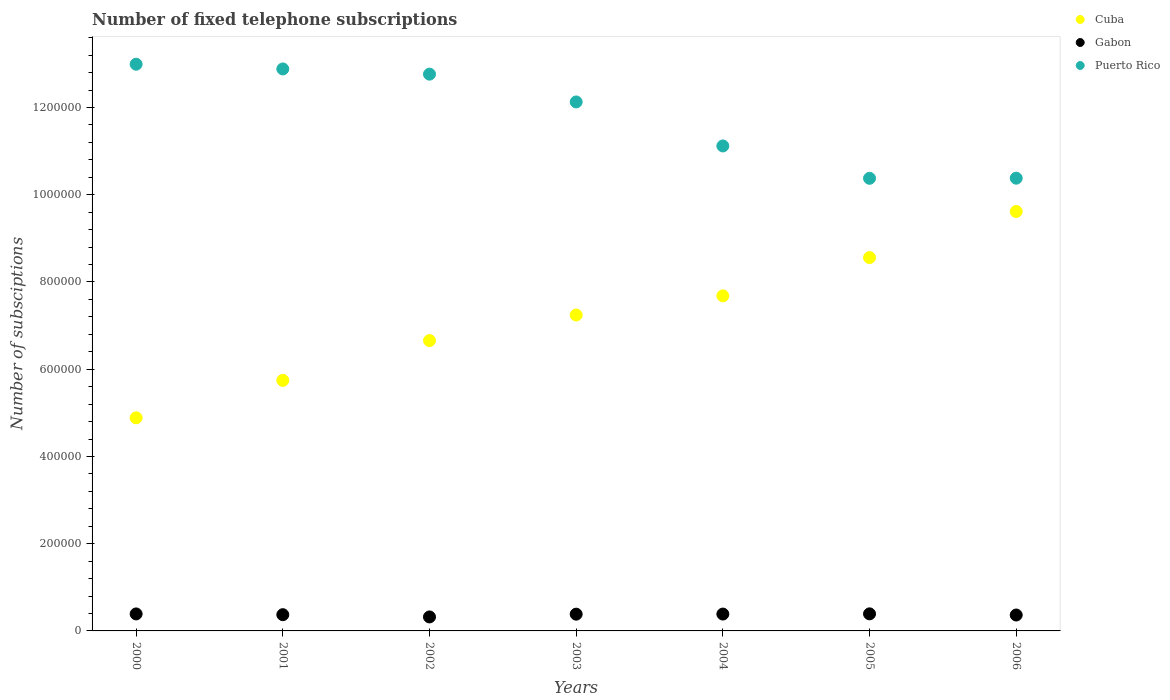How many different coloured dotlines are there?
Ensure brevity in your answer.  3. Is the number of dotlines equal to the number of legend labels?
Your answer should be very brief. Yes. What is the number of fixed telephone subscriptions in Puerto Rico in 2002?
Ensure brevity in your answer.  1.28e+06. Across all years, what is the maximum number of fixed telephone subscriptions in Gabon?
Keep it short and to the point. 3.91e+04. Across all years, what is the minimum number of fixed telephone subscriptions in Cuba?
Offer a very short reply. 4.89e+05. In which year was the number of fixed telephone subscriptions in Puerto Rico minimum?
Give a very brief answer. 2005. What is the total number of fixed telephone subscriptions in Gabon in the graph?
Offer a terse response. 2.61e+05. What is the difference between the number of fixed telephone subscriptions in Gabon in 2002 and that in 2004?
Provide a short and direct response. -6579. What is the difference between the number of fixed telephone subscriptions in Gabon in 2002 and the number of fixed telephone subscriptions in Puerto Rico in 2003?
Your answer should be very brief. -1.18e+06. What is the average number of fixed telephone subscriptions in Cuba per year?
Provide a short and direct response. 7.20e+05. In the year 2001, what is the difference between the number of fixed telephone subscriptions in Puerto Rico and number of fixed telephone subscriptions in Cuba?
Your answer should be very brief. 7.14e+05. What is the ratio of the number of fixed telephone subscriptions in Cuba in 2000 to that in 2001?
Make the answer very short. 0.85. Is the number of fixed telephone subscriptions in Puerto Rico in 2000 less than that in 2001?
Give a very brief answer. No. What is the difference between the highest and the second highest number of fixed telephone subscriptions in Puerto Rico?
Your answer should be very brief. 1.09e+04. What is the difference between the highest and the lowest number of fixed telephone subscriptions in Puerto Rico?
Give a very brief answer. 2.62e+05. In how many years, is the number of fixed telephone subscriptions in Puerto Rico greater than the average number of fixed telephone subscriptions in Puerto Rico taken over all years?
Your response must be concise. 4. Is the sum of the number of fixed telephone subscriptions in Gabon in 2001 and 2003 greater than the maximum number of fixed telephone subscriptions in Puerto Rico across all years?
Keep it short and to the point. No. Is it the case that in every year, the sum of the number of fixed telephone subscriptions in Puerto Rico and number of fixed telephone subscriptions in Gabon  is greater than the number of fixed telephone subscriptions in Cuba?
Keep it short and to the point. Yes. Is the number of fixed telephone subscriptions in Gabon strictly greater than the number of fixed telephone subscriptions in Cuba over the years?
Your response must be concise. No. How many dotlines are there?
Your answer should be compact. 3. Are the values on the major ticks of Y-axis written in scientific E-notation?
Make the answer very short. No. Where does the legend appear in the graph?
Your answer should be compact. Top right. What is the title of the graph?
Your answer should be very brief. Number of fixed telephone subscriptions. Does "Greenland" appear as one of the legend labels in the graph?
Your answer should be very brief. No. What is the label or title of the Y-axis?
Provide a short and direct response. Number of subsciptions. What is the Number of subsciptions of Cuba in 2000?
Your response must be concise. 4.89e+05. What is the Number of subsciptions of Gabon in 2000?
Make the answer very short. 3.90e+04. What is the Number of subsciptions in Puerto Rico in 2000?
Offer a terse response. 1.30e+06. What is the Number of subsciptions of Cuba in 2001?
Offer a very short reply. 5.74e+05. What is the Number of subsciptions in Gabon in 2001?
Keep it short and to the point. 3.72e+04. What is the Number of subsciptions in Puerto Rico in 2001?
Your answer should be very brief. 1.29e+06. What is the Number of subsciptions of Cuba in 2002?
Your answer should be very brief. 6.66e+05. What is the Number of subsciptions of Gabon in 2002?
Your answer should be very brief. 3.21e+04. What is the Number of subsciptions of Puerto Rico in 2002?
Your answer should be compact. 1.28e+06. What is the Number of subsciptions of Cuba in 2003?
Your answer should be very brief. 7.24e+05. What is the Number of subsciptions of Gabon in 2003?
Provide a short and direct response. 3.84e+04. What is the Number of subsciptions of Puerto Rico in 2003?
Give a very brief answer. 1.21e+06. What is the Number of subsciptions in Cuba in 2004?
Offer a terse response. 7.68e+05. What is the Number of subsciptions of Gabon in 2004?
Your answer should be very brief. 3.87e+04. What is the Number of subsciptions of Puerto Rico in 2004?
Your answer should be very brief. 1.11e+06. What is the Number of subsciptions of Cuba in 2005?
Make the answer very short. 8.56e+05. What is the Number of subsciptions in Gabon in 2005?
Your response must be concise. 3.91e+04. What is the Number of subsciptions of Puerto Rico in 2005?
Your response must be concise. 1.04e+06. What is the Number of subsciptions of Cuba in 2006?
Provide a succinct answer. 9.62e+05. What is the Number of subsciptions of Gabon in 2006?
Offer a terse response. 3.65e+04. What is the Number of subsciptions of Puerto Rico in 2006?
Your response must be concise. 1.04e+06. Across all years, what is the maximum Number of subsciptions of Cuba?
Offer a terse response. 9.62e+05. Across all years, what is the maximum Number of subsciptions of Gabon?
Offer a very short reply. 3.91e+04. Across all years, what is the maximum Number of subsciptions in Puerto Rico?
Your response must be concise. 1.30e+06. Across all years, what is the minimum Number of subsciptions of Cuba?
Provide a succinct answer. 4.89e+05. Across all years, what is the minimum Number of subsciptions of Gabon?
Provide a succinct answer. 3.21e+04. Across all years, what is the minimum Number of subsciptions in Puerto Rico?
Make the answer very short. 1.04e+06. What is the total Number of subsciptions of Cuba in the graph?
Your response must be concise. 5.04e+06. What is the total Number of subsciptions of Gabon in the graph?
Make the answer very short. 2.61e+05. What is the total Number of subsciptions in Puerto Rico in the graph?
Keep it short and to the point. 8.26e+06. What is the difference between the Number of subsciptions in Cuba in 2000 and that in 2001?
Provide a short and direct response. -8.58e+04. What is the difference between the Number of subsciptions of Gabon in 2000 and that in 2001?
Keep it short and to the point. 1741. What is the difference between the Number of subsciptions of Puerto Rico in 2000 and that in 2001?
Offer a terse response. 1.09e+04. What is the difference between the Number of subsciptions in Cuba in 2000 and that in 2002?
Your response must be concise. -1.77e+05. What is the difference between the Number of subsciptions in Gabon in 2000 and that in 2002?
Your response must be concise. 6899. What is the difference between the Number of subsciptions in Puerto Rico in 2000 and that in 2002?
Offer a very short reply. 2.28e+04. What is the difference between the Number of subsciptions of Cuba in 2000 and that in 2003?
Ensure brevity in your answer.  -2.36e+05. What is the difference between the Number of subsciptions of Gabon in 2000 and that in 2003?
Provide a short and direct response. 559. What is the difference between the Number of subsciptions in Puerto Rico in 2000 and that in 2003?
Give a very brief answer. 8.65e+04. What is the difference between the Number of subsciptions in Cuba in 2000 and that in 2004?
Offer a terse response. -2.80e+05. What is the difference between the Number of subsciptions of Gabon in 2000 and that in 2004?
Ensure brevity in your answer.  320. What is the difference between the Number of subsciptions of Puerto Rico in 2000 and that in 2004?
Provide a succinct answer. 1.87e+05. What is the difference between the Number of subsciptions of Cuba in 2000 and that in 2005?
Your answer should be compact. -3.67e+05. What is the difference between the Number of subsciptions in Gabon in 2000 and that in 2005?
Your response must be concise. -154. What is the difference between the Number of subsciptions of Puerto Rico in 2000 and that in 2005?
Provide a succinct answer. 2.62e+05. What is the difference between the Number of subsciptions of Cuba in 2000 and that in 2006?
Your response must be concise. -4.73e+05. What is the difference between the Number of subsciptions in Gabon in 2000 and that in 2006?
Make the answer very short. 2498. What is the difference between the Number of subsciptions in Puerto Rico in 2000 and that in 2006?
Your answer should be compact. 2.61e+05. What is the difference between the Number of subsciptions of Cuba in 2001 and that in 2002?
Your answer should be compact. -9.12e+04. What is the difference between the Number of subsciptions in Gabon in 2001 and that in 2002?
Provide a succinct answer. 5158. What is the difference between the Number of subsciptions in Puerto Rico in 2001 and that in 2002?
Ensure brevity in your answer.  1.19e+04. What is the difference between the Number of subsciptions of Cuba in 2001 and that in 2003?
Keep it short and to the point. -1.50e+05. What is the difference between the Number of subsciptions in Gabon in 2001 and that in 2003?
Provide a succinct answer. -1182. What is the difference between the Number of subsciptions of Puerto Rico in 2001 and that in 2003?
Your response must be concise. 7.57e+04. What is the difference between the Number of subsciptions of Cuba in 2001 and that in 2004?
Give a very brief answer. -1.94e+05. What is the difference between the Number of subsciptions of Gabon in 2001 and that in 2004?
Your answer should be compact. -1421. What is the difference between the Number of subsciptions in Puerto Rico in 2001 and that in 2004?
Your answer should be compact. 1.77e+05. What is the difference between the Number of subsciptions of Cuba in 2001 and that in 2005?
Your answer should be very brief. -2.82e+05. What is the difference between the Number of subsciptions of Gabon in 2001 and that in 2005?
Keep it short and to the point. -1895. What is the difference between the Number of subsciptions of Puerto Rico in 2001 and that in 2005?
Your answer should be compact. 2.51e+05. What is the difference between the Number of subsciptions in Cuba in 2001 and that in 2006?
Provide a short and direct response. -3.87e+05. What is the difference between the Number of subsciptions of Gabon in 2001 and that in 2006?
Your answer should be compact. 757. What is the difference between the Number of subsciptions of Puerto Rico in 2001 and that in 2006?
Keep it short and to the point. 2.50e+05. What is the difference between the Number of subsciptions in Cuba in 2002 and that in 2003?
Provide a succinct answer. -5.86e+04. What is the difference between the Number of subsciptions of Gabon in 2002 and that in 2003?
Give a very brief answer. -6340. What is the difference between the Number of subsciptions of Puerto Rico in 2002 and that in 2003?
Provide a succinct answer. 6.37e+04. What is the difference between the Number of subsciptions in Cuba in 2002 and that in 2004?
Your answer should be very brief. -1.03e+05. What is the difference between the Number of subsciptions in Gabon in 2002 and that in 2004?
Offer a very short reply. -6579. What is the difference between the Number of subsciptions of Puerto Rico in 2002 and that in 2004?
Your answer should be very brief. 1.65e+05. What is the difference between the Number of subsciptions of Cuba in 2002 and that in 2005?
Your response must be concise. -1.90e+05. What is the difference between the Number of subsciptions of Gabon in 2002 and that in 2005?
Provide a short and direct response. -7053. What is the difference between the Number of subsciptions in Puerto Rico in 2002 and that in 2005?
Provide a succinct answer. 2.39e+05. What is the difference between the Number of subsciptions in Cuba in 2002 and that in 2006?
Offer a very short reply. -2.96e+05. What is the difference between the Number of subsciptions in Gabon in 2002 and that in 2006?
Keep it short and to the point. -4401. What is the difference between the Number of subsciptions in Puerto Rico in 2002 and that in 2006?
Your answer should be very brief. 2.38e+05. What is the difference between the Number of subsciptions in Cuba in 2003 and that in 2004?
Make the answer very short. -4.39e+04. What is the difference between the Number of subsciptions in Gabon in 2003 and that in 2004?
Give a very brief answer. -239. What is the difference between the Number of subsciptions of Puerto Rico in 2003 and that in 2004?
Offer a very short reply. 1.01e+05. What is the difference between the Number of subsciptions in Cuba in 2003 and that in 2005?
Provide a succinct answer. -1.32e+05. What is the difference between the Number of subsciptions in Gabon in 2003 and that in 2005?
Make the answer very short. -713. What is the difference between the Number of subsciptions in Puerto Rico in 2003 and that in 2005?
Your answer should be very brief. 1.75e+05. What is the difference between the Number of subsciptions of Cuba in 2003 and that in 2006?
Ensure brevity in your answer.  -2.37e+05. What is the difference between the Number of subsciptions of Gabon in 2003 and that in 2006?
Your answer should be compact. 1939. What is the difference between the Number of subsciptions of Puerto Rico in 2003 and that in 2006?
Make the answer very short. 1.75e+05. What is the difference between the Number of subsciptions in Cuba in 2004 and that in 2005?
Make the answer very short. -8.78e+04. What is the difference between the Number of subsciptions in Gabon in 2004 and that in 2005?
Give a very brief answer. -474. What is the difference between the Number of subsciptions of Puerto Rico in 2004 and that in 2005?
Provide a succinct answer. 7.42e+04. What is the difference between the Number of subsciptions in Cuba in 2004 and that in 2006?
Give a very brief answer. -1.93e+05. What is the difference between the Number of subsciptions of Gabon in 2004 and that in 2006?
Make the answer very short. 2178. What is the difference between the Number of subsciptions in Puerto Rico in 2004 and that in 2006?
Offer a terse response. 7.39e+04. What is the difference between the Number of subsciptions of Cuba in 2005 and that in 2006?
Provide a short and direct response. -1.06e+05. What is the difference between the Number of subsciptions of Gabon in 2005 and that in 2006?
Make the answer very short. 2652. What is the difference between the Number of subsciptions of Puerto Rico in 2005 and that in 2006?
Give a very brief answer. -300. What is the difference between the Number of subsciptions in Cuba in 2000 and the Number of subsciptions in Gabon in 2001?
Offer a terse response. 4.51e+05. What is the difference between the Number of subsciptions of Cuba in 2000 and the Number of subsciptions of Puerto Rico in 2001?
Ensure brevity in your answer.  -8.00e+05. What is the difference between the Number of subsciptions in Gabon in 2000 and the Number of subsciptions in Puerto Rico in 2001?
Make the answer very short. -1.25e+06. What is the difference between the Number of subsciptions of Cuba in 2000 and the Number of subsciptions of Gabon in 2002?
Provide a short and direct response. 4.57e+05. What is the difference between the Number of subsciptions of Cuba in 2000 and the Number of subsciptions of Puerto Rico in 2002?
Give a very brief answer. -7.88e+05. What is the difference between the Number of subsciptions of Gabon in 2000 and the Number of subsciptions of Puerto Rico in 2002?
Offer a terse response. -1.24e+06. What is the difference between the Number of subsciptions of Cuba in 2000 and the Number of subsciptions of Gabon in 2003?
Your answer should be very brief. 4.50e+05. What is the difference between the Number of subsciptions of Cuba in 2000 and the Number of subsciptions of Puerto Rico in 2003?
Provide a short and direct response. -7.24e+05. What is the difference between the Number of subsciptions in Gabon in 2000 and the Number of subsciptions in Puerto Rico in 2003?
Offer a very short reply. -1.17e+06. What is the difference between the Number of subsciptions in Cuba in 2000 and the Number of subsciptions in Gabon in 2004?
Provide a short and direct response. 4.50e+05. What is the difference between the Number of subsciptions in Cuba in 2000 and the Number of subsciptions in Puerto Rico in 2004?
Offer a very short reply. -6.23e+05. What is the difference between the Number of subsciptions of Gabon in 2000 and the Number of subsciptions of Puerto Rico in 2004?
Offer a very short reply. -1.07e+06. What is the difference between the Number of subsciptions in Cuba in 2000 and the Number of subsciptions in Gabon in 2005?
Offer a terse response. 4.49e+05. What is the difference between the Number of subsciptions of Cuba in 2000 and the Number of subsciptions of Puerto Rico in 2005?
Offer a terse response. -5.49e+05. What is the difference between the Number of subsciptions of Gabon in 2000 and the Number of subsciptions of Puerto Rico in 2005?
Ensure brevity in your answer.  -9.99e+05. What is the difference between the Number of subsciptions in Cuba in 2000 and the Number of subsciptions in Gabon in 2006?
Offer a terse response. 4.52e+05. What is the difference between the Number of subsciptions of Cuba in 2000 and the Number of subsciptions of Puerto Rico in 2006?
Your answer should be very brief. -5.49e+05. What is the difference between the Number of subsciptions of Gabon in 2000 and the Number of subsciptions of Puerto Rico in 2006?
Provide a short and direct response. -9.99e+05. What is the difference between the Number of subsciptions of Cuba in 2001 and the Number of subsciptions of Gabon in 2002?
Keep it short and to the point. 5.42e+05. What is the difference between the Number of subsciptions of Cuba in 2001 and the Number of subsciptions of Puerto Rico in 2002?
Provide a succinct answer. -7.02e+05. What is the difference between the Number of subsciptions of Gabon in 2001 and the Number of subsciptions of Puerto Rico in 2002?
Your answer should be compact. -1.24e+06. What is the difference between the Number of subsciptions of Cuba in 2001 and the Number of subsciptions of Gabon in 2003?
Your response must be concise. 5.36e+05. What is the difference between the Number of subsciptions in Cuba in 2001 and the Number of subsciptions in Puerto Rico in 2003?
Ensure brevity in your answer.  -6.38e+05. What is the difference between the Number of subsciptions of Gabon in 2001 and the Number of subsciptions of Puerto Rico in 2003?
Your answer should be very brief. -1.18e+06. What is the difference between the Number of subsciptions of Cuba in 2001 and the Number of subsciptions of Gabon in 2004?
Your answer should be compact. 5.36e+05. What is the difference between the Number of subsciptions in Cuba in 2001 and the Number of subsciptions in Puerto Rico in 2004?
Your response must be concise. -5.37e+05. What is the difference between the Number of subsciptions in Gabon in 2001 and the Number of subsciptions in Puerto Rico in 2004?
Provide a succinct answer. -1.07e+06. What is the difference between the Number of subsciptions of Cuba in 2001 and the Number of subsciptions of Gabon in 2005?
Ensure brevity in your answer.  5.35e+05. What is the difference between the Number of subsciptions of Cuba in 2001 and the Number of subsciptions of Puerto Rico in 2005?
Your answer should be compact. -4.63e+05. What is the difference between the Number of subsciptions of Gabon in 2001 and the Number of subsciptions of Puerto Rico in 2005?
Ensure brevity in your answer.  -1.00e+06. What is the difference between the Number of subsciptions in Cuba in 2001 and the Number of subsciptions in Gabon in 2006?
Ensure brevity in your answer.  5.38e+05. What is the difference between the Number of subsciptions in Cuba in 2001 and the Number of subsciptions in Puerto Rico in 2006?
Your answer should be very brief. -4.64e+05. What is the difference between the Number of subsciptions in Gabon in 2001 and the Number of subsciptions in Puerto Rico in 2006?
Offer a very short reply. -1.00e+06. What is the difference between the Number of subsciptions in Cuba in 2002 and the Number of subsciptions in Gabon in 2003?
Your answer should be compact. 6.27e+05. What is the difference between the Number of subsciptions of Cuba in 2002 and the Number of subsciptions of Puerto Rico in 2003?
Keep it short and to the point. -5.47e+05. What is the difference between the Number of subsciptions in Gabon in 2002 and the Number of subsciptions in Puerto Rico in 2003?
Provide a succinct answer. -1.18e+06. What is the difference between the Number of subsciptions of Cuba in 2002 and the Number of subsciptions of Gabon in 2004?
Provide a succinct answer. 6.27e+05. What is the difference between the Number of subsciptions in Cuba in 2002 and the Number of subsciptions in Puerto Rico in 2004?
Keep it short and to the point. -4.46e+05. What is the difference between the Number of subsciptions of Gabon in 2002 and the Number of subsciptions of Puerto Rico in 2004?
Your answer should be very brief. -1.08e+06. What is the difference between the Number of subsciptions of Cuba in 2002 and the Number of subsciptions of Gabon in 2005?
Ensure brevity in your answer.  6.27e+05. What is the difference between the Number of subsciptions of Cuba in 2002 and the Number of subsciptions of Puerto Rico in 2005?
Ensure brevity in your answer.  -3.72e+05. What is the difference between the Number of subsciptions of Gabon in 2002 and the Number of subsciptions of Puerto Rico in 2005?
Keep it short and to the point. -1.01e+06. What is the difference between the Number of subsciptions of Cuba in 2002 and the Number of subsciptions of Gabon in 2006?
Your answer should be compact. 6.29e+05. What is the difference between the Number of subsciptions of Cuba in 2002 and the Number of subsciptions of Puerto Rico in 2006?
Offer a very short reply. -3.72e+05. What is the difference between the Number of subsciptions in Gabon in 2002 and the Number of subsciptions in Puerto Rico in 2006?
Your answer should be compact. -1.01e+06. What is the difference between the Number of subsciptions in Cuba in 2003 and the Number of subsciptions in Gabon in 2004?
Ensure brevity in your answer.  6.86e+05. What is the difference between the Number of subsciptions in Cuba in 2003 and the Number of subsciptions in Puerto Rico in 2004?
Your response must be concise. -3.88e+05. What is the difference between the Number of subsciptions of Gabon in 2003 and the Number of subsciptions of Puerto Rico in 2004?
Offer a terse response. -1.07e+06. What is the difference between the Number of subsciptions in Cuba in 2003 and the Number of subsciptions in Gabon in 2005?
Provide a short and direct response. 6.85e+05. What is the difference between the Number of subsciptions of Cuba in 2003 and the Number of subsciptions of Puerto Rico in 2005?
Ensure brevity in your answer.  -3.13e+05. What is the difference between the Number of subsciptions of Gabon in 2003 and the Number of subsciptions of Puerto Rico in 2005?
Provide a short and direct response. -9.99e+05. What is the difference between the Number of subsciptions of Cuba in 2003 and the Number of subsciptions of Gabon in 2006?
Make the answer very short. 6.88e+05. What is the difference between the Number of subsciptions in Cuba in 2003 and the Number of subsciptions in Puerto Rico in 2006?
Keep it short and to the point. -3.14e+05. What is the difference between the Number of subsciptions of Gabon in 2003 and the Number of subsciptions of Puerto Rico in 2006?
Give a very brief answer. -1.00e+06. What is the difference between the Number of subsciptions of Cuba in 2004 and the Number of subsciptions of Gabon in 2005?
Offer a terse response. 7.29e+05. What is the difference between the Number of subsciptions of Cuba in 2004 and the Number of subsciptions of Puerto Rico in 2005?
Offer a very short reply. -2.70e+05. What is the difference between the Number of subsciptions in Gabon in 2004 and the Number of subsciptions in Puerto Rico in 2005?
Provide a succinct answer. -9.99e+05. What is the difference between the Number of subsciptions in Cuba in 2004 and the Number of subsciptions in Gabon in 2006?
Provide a short and direct response. 7.32e+05. What is the difference between the Number of subsciptions in Cuba in 2004 and the Number of subsciptions in Puerto Rico in 2006?
Your answer should be compact. -2.70e+05. What is the difference between the Number of subsciptions in Gabon in 2004 and the Number of subsciptions in Puerto Rico in 2006?
Keep it short and to the point. -9.99e+05. What is the difference between the Number of subsciptions in Cuba in 2005 and the Number of subsciptions in Gabon in 2006?
Provide a succinct answer. 8.19e+05. What is the difference between the Number of subsciptions in Cuba in 2005 and the Number of subsciptions in Puerto Rico in 2006?
Your answer should be very brief. -1.82e+05. What is the difference between the Number of subsciptions in Gabon in 2005 and the Number of subsciptions in Puerto Rico in 2006?
Keep it short and to the point. -9.99e+05. What is the average Number of subsciptions of Cuba per year?
Your response must be concise. 7.20e+05. What is the average Number of subsciptions in Gabon per year?
Ensure brevity in your answer.  3.73e+04. What is the average Number of subsciptions of Puerto Rico per year?
Make the answer very short. 1.18e+06. In the year 2000, what is the difference between the Number of subsciptions in Cuba and Number of subsciptions in Gabon?
Ensure brevity in your answer.  4.50e+05. In the year 2000, what is the difference between the Number of subsciptions of Cuba and Number of subsciptions of Puerto Rico?
Provide a short and direct response. -8.11e+05. In the year 2000, what is the difference between the Number of subsciptions in Gabon and Number of subsciptions in Puerto Rico?
Give a very brief answer. -1.26e+06. In the year 2001, what is the difference between the Number of subsciptions in Cuba and Number of subsciptions in Gabon?
Ensure brevity in your answer.  5.37e+05. In the year 2001, what is the difference between the Number of subsciptions of Cuba and Number of subsciptions of Puerto Rico?
Keep it short and to the point. -7.14e+05. In the year 2001, what is the difference between the Number of subsciptions of Gabon and Number of subsciptions of Puerto Rico?
Your answer should be compact. -1.25e+06. In the year 2002, what is the difference between the Number of subsciptions in Cuba and Number of subsciptions in Gabon?
Offer a very short reply. 6.34e+05. In the year 2002, what is the difference between the Number of subsciptions of Cuba and Number of subsciptions of Puerto Rico?
Offer a terse response. -6.11e+05. In the year 2002, what is the difference between the Number of subsciptions of Gabon and Number of subsciptions of Puerto Rico?
Your answer should be compact. -1.24e+06. In the year 2003, what is the difference between the Number of subsciptions in Cuba and Number of subsciptions in Gabon?
Offer a very short reply. 6.86e+05. In the year 2003, what is the difference between the Number of subsciptions of Cuba and Number of subsciptions of Puerto Rico?
Your answer should be compact. -4.89e+05. In the year 2003, what is the difference between the Number of subsciptions in Gabon and Number of subsciptions in Puerto Rico?
Offer a terse response. -1.17e+06. In the year 2004, what is the difference between the Number of subsciptions in Cuba and Number of subsciptions in Gabon?
Give a very brief answer. 7.30e+05. In the year 2004, what is the difference between the Number of subsciptions of Cuba and Number of subsciptions of Puerto Rico?
Offer a terse response. -3.44e+05. In the year 2004, what is the difference between the Number of subsciptions of Gabon and Number of subsciptions of Puerto Rico?
Offer a very short reply. -1.07e+06. In the year 2005, what is the difference between the Number of subsciptions in Cuba and Number of subsciptions in Gabon?
Provide a short and direct response. 8.17e+05. In the year 2005, what is the difference between the Number of subsciptions in Cuba and Number of subsciptions in Puerto Rico?
Give a very brief answer. -1.82e+05. In the year 2005, what is the difference between the Number of subsciptions in Gabon and Number of subsciptions in Puerto Rico?
Offer a very short reply. -9.99e+05. In the year 2006, what is the difference between the Number of subsciptions in Cuba and Number of subsciptions in Gabon?
Offer a very short reply. 9.25e+05. In the year 2006, what is the difference between the Number of subsciptions in Cuba and Number of subsciptions in Puerto Rico?
Offer a very short reply. -7.64e+04. In the year 2006, what is the difference between the Number of subsciptions of Gabon and Number of subsciptions of Puerto Rico?
Make the answer very short. -1.00e+06. What is the ratio of the Number of subsciptions of Cuba in 2000 to that in 2001?
Provide a succinct answer. 0.85. What is the ratio of the Number of subsciptions of Gabon in 2000 to that in 2001?
Provide a short and direct response. 1.05. What is the ratio of the Number of subsciptions in Puerto Rico in 2000 to that in 2001?
Make the answer very short. 1.01. What is the ratio of the Number of subsciptions of Cuba in 2000 to that in 2002?
Your answer should be compact. 0.73. What is the ratio of the Number of subsciptions in Gabon in 2000 to that in 2002?
Your answer should be very brief. 1.22. What is the ratio of the Number of subsciptions in Puerto Rico in 2000 to that in 2002?
Offer a very short reply. 1.02. What is the ratio of the Number of subsciptions in Cuba in 2000 to that in 2003?
Ensure brevity in your answer.  0.67. What is the ratio of the Number of subsciptions in Gabon in 2000 to that in 2003?
Keep it short and to the point. 1.01. What is the ratio of the Number of subsciptions of Puerto Rico in 2000 to that in 2003?
Offer a terse response. 1.07. What is the ratio of the Number of subsciptions in Cuba in 2000 to that in 2004?
Offer a terse response. 0.64. What is the ratio of the Number of subsciptions of Gabon in 2000 to that in 2004?
Offer a terse response. 1.01. What is the ratio of the Number of subsciptions in Puerto Rico in 2000 to that in 2004?
Your response must be concise. 1.17. What is the ratio of the Number of subsciptions in Cuba in 2000 to that in 2005?
Provide a succinct answer. 0.57. What is the ratio of the Number of subsciptions in Gabon in 2000 to that in 2005?
Ensure brevity in your answer.  1. What is the ratio of the Number of subsciptions of Puerto Rico in 2000 to that in 2005?
Offer a very short reply. 1.25. What is the ratio of the Number of subsciptions of Cuba in 2000 to that in 2006?
Ensure brevity in your answer.  0.51. What is the ratio of the Number of subsciptions in Gabon in 2000 to that in 2006?
Offer a very short reply. 1.07. What is the ratio of the Number of subsciptions in Puerto Rico in 2000 to that in 2006?
Your answer should be compact. 1.25. What is the ratio of the Number of subsciptions of Cuba in 2001 to that in 2002?
Ensure brevity in your answer.  0.86. What is the ratio of the Number of subsciptions in Gabon in 2001 to that in 2002?
Keep it short and to the point. 1.16. What is the ratio of the Number of subsciptions in Puerto Rico in 2001 to that in 2002?
Offer a terse response. 1.01. What is the ratio of the Number of subsciptions in Cuba in 2001 to that in 2003?
Your answer should be compact. 0.79. What is the ratio of the Number of subsciptions in Gabon in 2001 to that in 2003?
Keep it short and to the point. 0.97. What is the ratio of the Number of subsciptions of Puerto Rico in 2001 to that in 2003?
Give a very brief answer. 1.06. What is the ratio of the Number of subsciptions in Cuba in 2001 to that in 2004?
Your answer should be very brief. 0.75. What is the ratio of the Number of subsciptions in Gabon in 2001 to that in 2004?
Your answer should be very brief. 0.96. What is the ratio of the Number of subsciptions in Puerto Rico in 2001 to that in 2004?
Give a very brief answer. 1.16. What is the ratio of the Number of subsciptions in Cuba in 2001 to that in 2005?
Make the answer very short. 0.67. What is the ratio of the Number of subsciptions in Gabon in 2001 to that in 2005?
Your answer should be compact. 0.95. What is the ratio of the Number of subsciptions of Puerto Rico in 2001 to that in 2005?
Your response must be concise. 1.24. What is the ratio of the Number of subsciptions in Cuba in 2001 to that in 2006?
Provide a succinct answer. 0.6. What is the ratio of the Number of subsciptions of Gabon in 2001 to that in 2006?
Offer a terse response. 1.02. What is the ratio of the Number of subsciptions in Puerto Rico in 2001 to that in 2006?
Provide a succinct answer. 1.24. What is the ratio of the Number of subsciptions of Cuba in 2002 to that in 2003?
Offer a terse response. 0.92. What is the ratio of the Number of subsciptions in Gabon in 2002 to that in 2003?
Provide a succinct answer. 0.83. What is the ratio of the Number of subsciptions in Puerto Rico in 2002 to that in 2003?
Make the answer very short. 1.05. What is the ratio of the Number of subsciptions of Cuba in 2002 to that in 2004?
Provide a short and direct response. 0.87. What is the ratio of the Number of subsciptions of Gabon in 2002 to that in 2004?
Offer a terse response. 0.83. What is the ratio of the Number of subsciptions of Puerto Rico in 2002 to that in 2004?
Provide a succinct answer. 1.15. What is the ratio of the Number of subsciptions in Cuba in 2002 to that in 2005?
Ensure brevity in your answer.  0.78. What is the ratio of the Number of subsciptions in Gabon in 2002 to that in 2005?
Give a very brief answer. 0.82. What is the ratio of the Number of subsciptions of Puerto Rico in 2002 to that in 2005?
Your response must be concise. 1.23. What is the ratio of the Number of subsciptions in Cuba in 2002 to that in 2006?
Provide a short and direct response. 0.69. What is the ratio of the Number of subsciptions of Gabon in 2002 to that in 2006?
Your response must be concise. 0.88. What is the ratio of the Number of subsciptions of Puerto Rico in 2002 to that in 2006?
Provide a succinct answer. 1.23. What is the ratio of the Number of subsciptions in Cuba in 2003 to that in 2004?
Keep it short and to the point. 0.94. What is the ratio of the Number of subsciptions in Gabon in 2003 to that in 2004?
Offer a terse response. 0.99. What is the ratio of the Number of subsciptions of Puerto Rico in 2003 to that in 2004?
Keep it short and to the point. 1.09. What is the ratio of the Number of subsciptions of Cuba in 2003 to that in 2005?
Provide a succinct answer. 0.85. What is the ratio of the Number of subsciptions in Gabon in 2003 to that in 2005?
Make the answer very short. 0.98. What is the ratio of the Number of subsciptions of Puerto Rico in 2003 to that in 2005?
Make the answer very short. 1.17. What is the ratio of the Number of subsciptions of Cuba in 2003 to that in 2006?
Your answer should be compact. 0.75. What is the ratio of the Number of subsciptions in Gabon in 2003 to that in 2006?
Your answer should be compact. 1.05. What is the ratio of the Number of subsciptions of Puerto Rico in 2003 to that in 2006?
Your response must be concise. 1.17. What is the ratio of the Number of subsciptions in Cuba in 2004 to that in 2005?
Keep it short and to the point. 0.9. What is the ratio of the Number of subsciptions in Gabon in 2004 to that in 2005?
Your answer should be very brief. 0.99. What is the ratio of the Number of subsciptions of Puerto Rico in 2004 to that in 2005?
Make the answer very short. 1.07. What is the ratio of the Number of subsciptions of Cuba in 2004 to that in 2006?
Offer a very short reply. 0.8. What is the ratio of the Number of subsciptions of Gabon in 2004 to that in 2006?
Make the answer very short. 1.06. What is the ratio of the Number of subsciptions in Puerto Rico in 2004 to that in 2006?
Your answer should be very brief. 1.07. What is the ratio of the Number of subsciptions in Cuba in 2005 to that in 2006?
Provide a short and direct response. 0.89. What is the ratio of the Number of subsciptions in Gabon in 2005 to that in 2006?
Your response must be concise. 1.07. What is the difference between the highest and the second highest Number of subsciptions in Cuba?
Your answer should be compact. 1.06e+05. What is the difference between the highest and the second highest Number of subsciptions in Gabon?
Make the answer very short. 154. What is the difference between the highest and the second highest Number of subsciptions in Puerto Rico?
Your answer should be very brief. 1.09e+04. What is the difference between the highest and the lowest Number of subsciptions of Cuba?
Provide a short and direct response. 4.73e+05. What is the difference between the highest and the lowest Number of subsciptions in Gabon?
Offer a terse response. 7053. What is the difference between the highest and the lowest Number of subsciptions of Puerto Rico?
Give a very brief answer. 2.62e+05. 